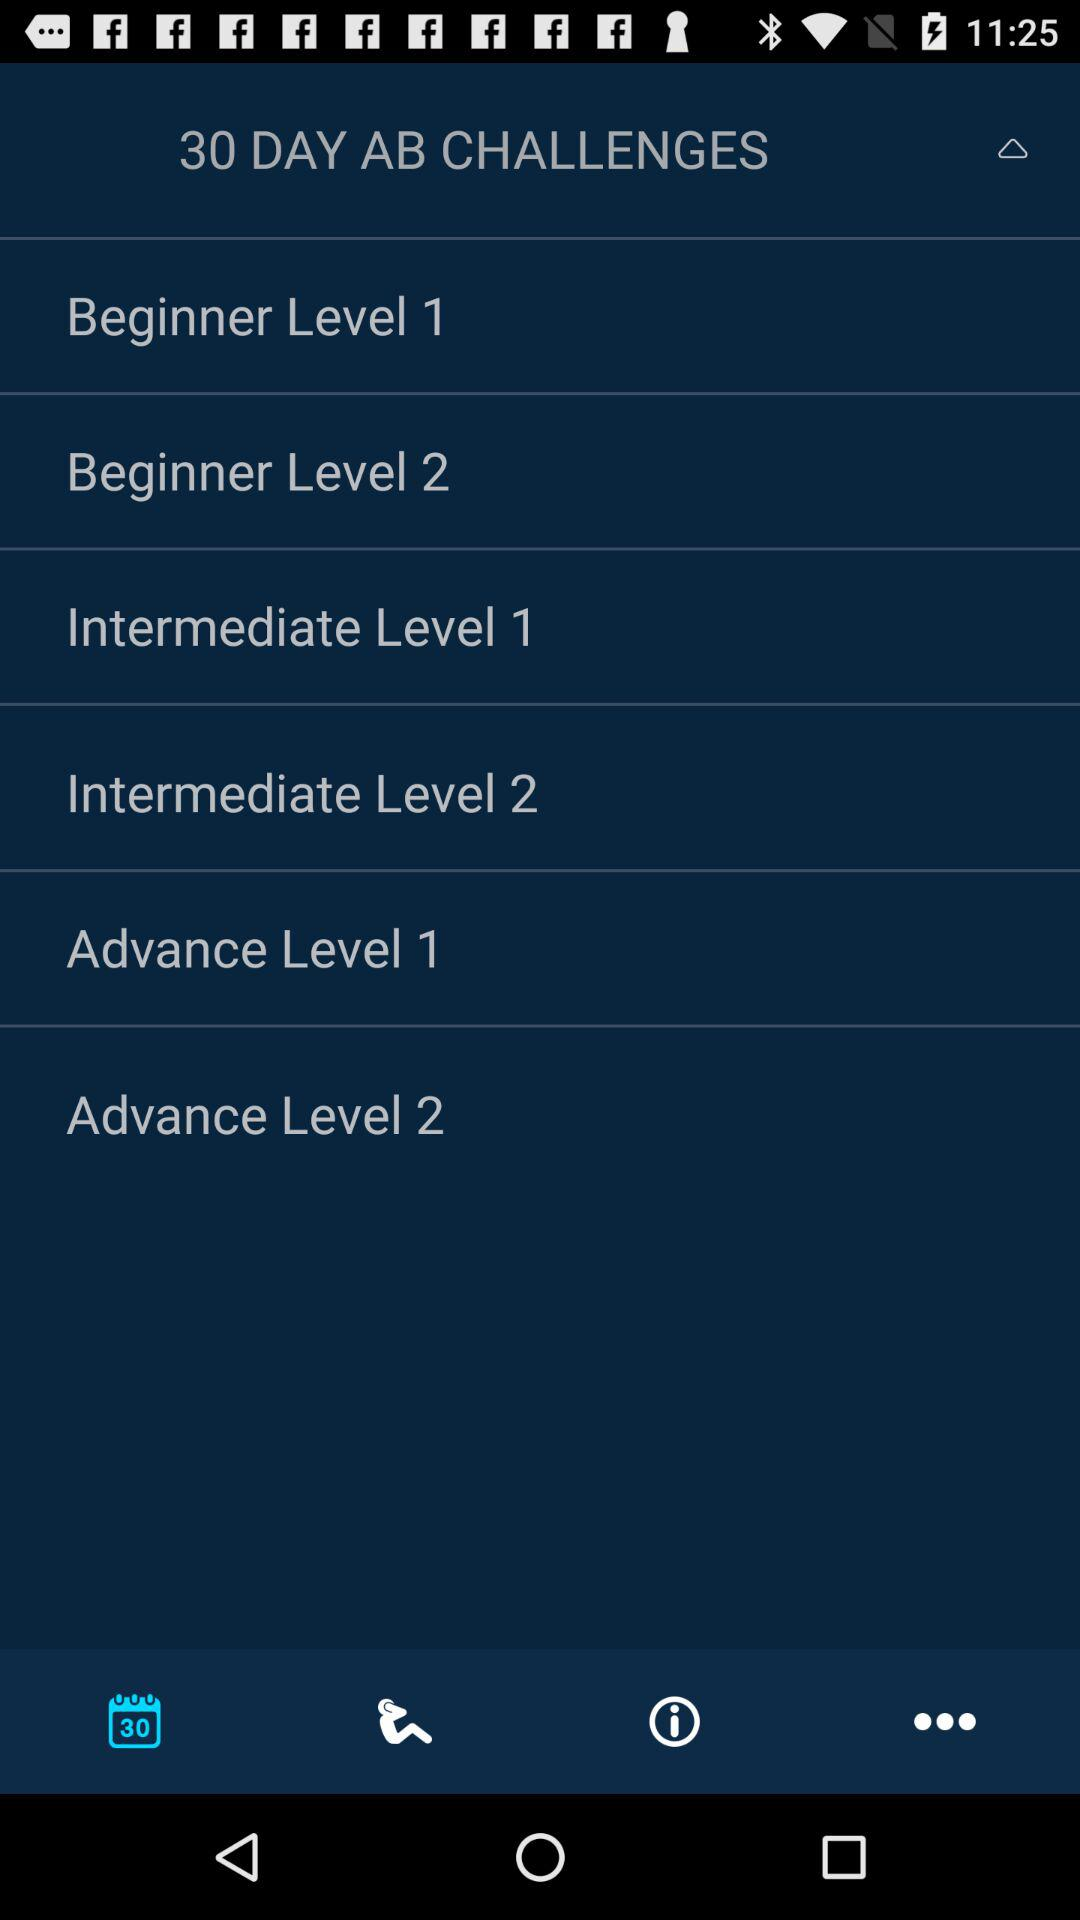How many levels are there for beginners?
Answer the question using a single word or phrase. 2 